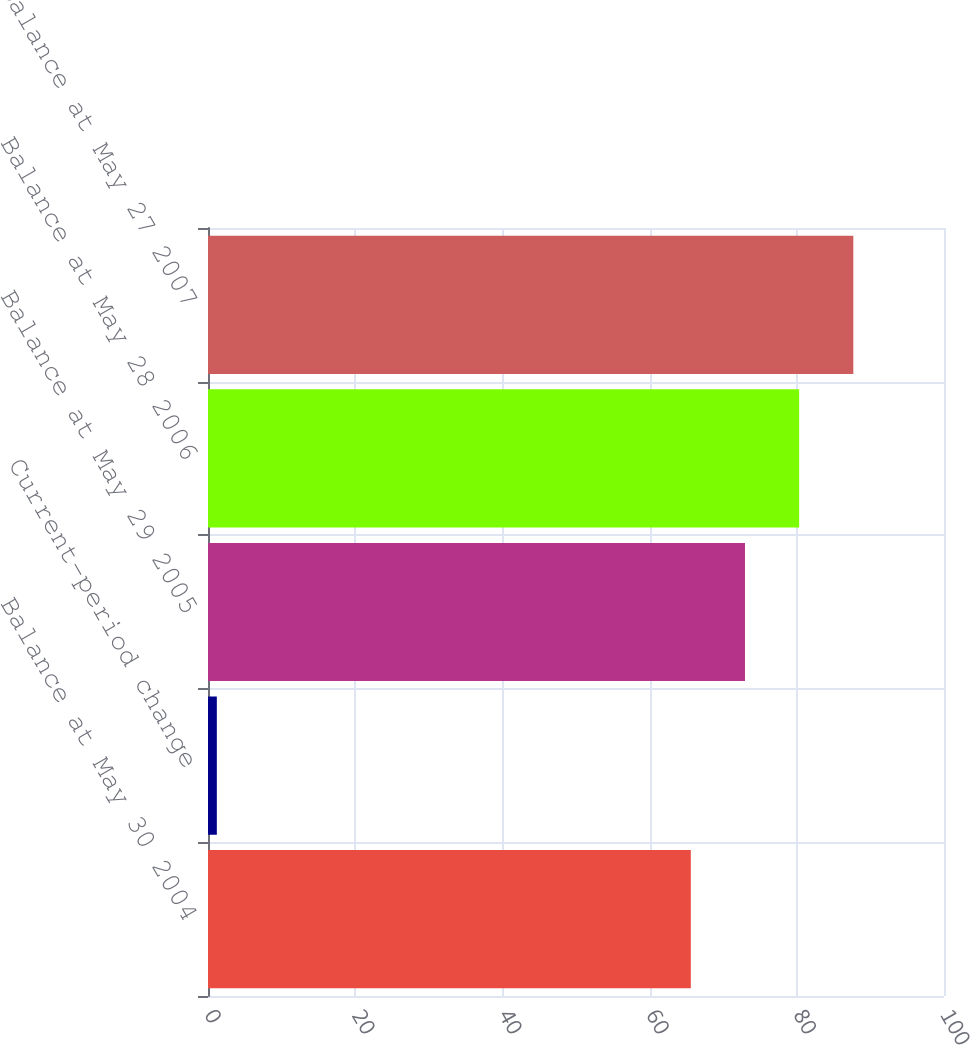<chart> <loc_0><loc_0><loc_500><loc_500><bar_chart><fcel>Balance at May 30 2004<fcel>Current-period change<fcel>Balance at May 29 2005<fcel>Balance at May 28 2006<fcel>Balance at May 27 2007<nl><fcel>65.6<fcel>1.2<fcel>72.96<fcel>80.32<fcel>87.68<nl></chart> 